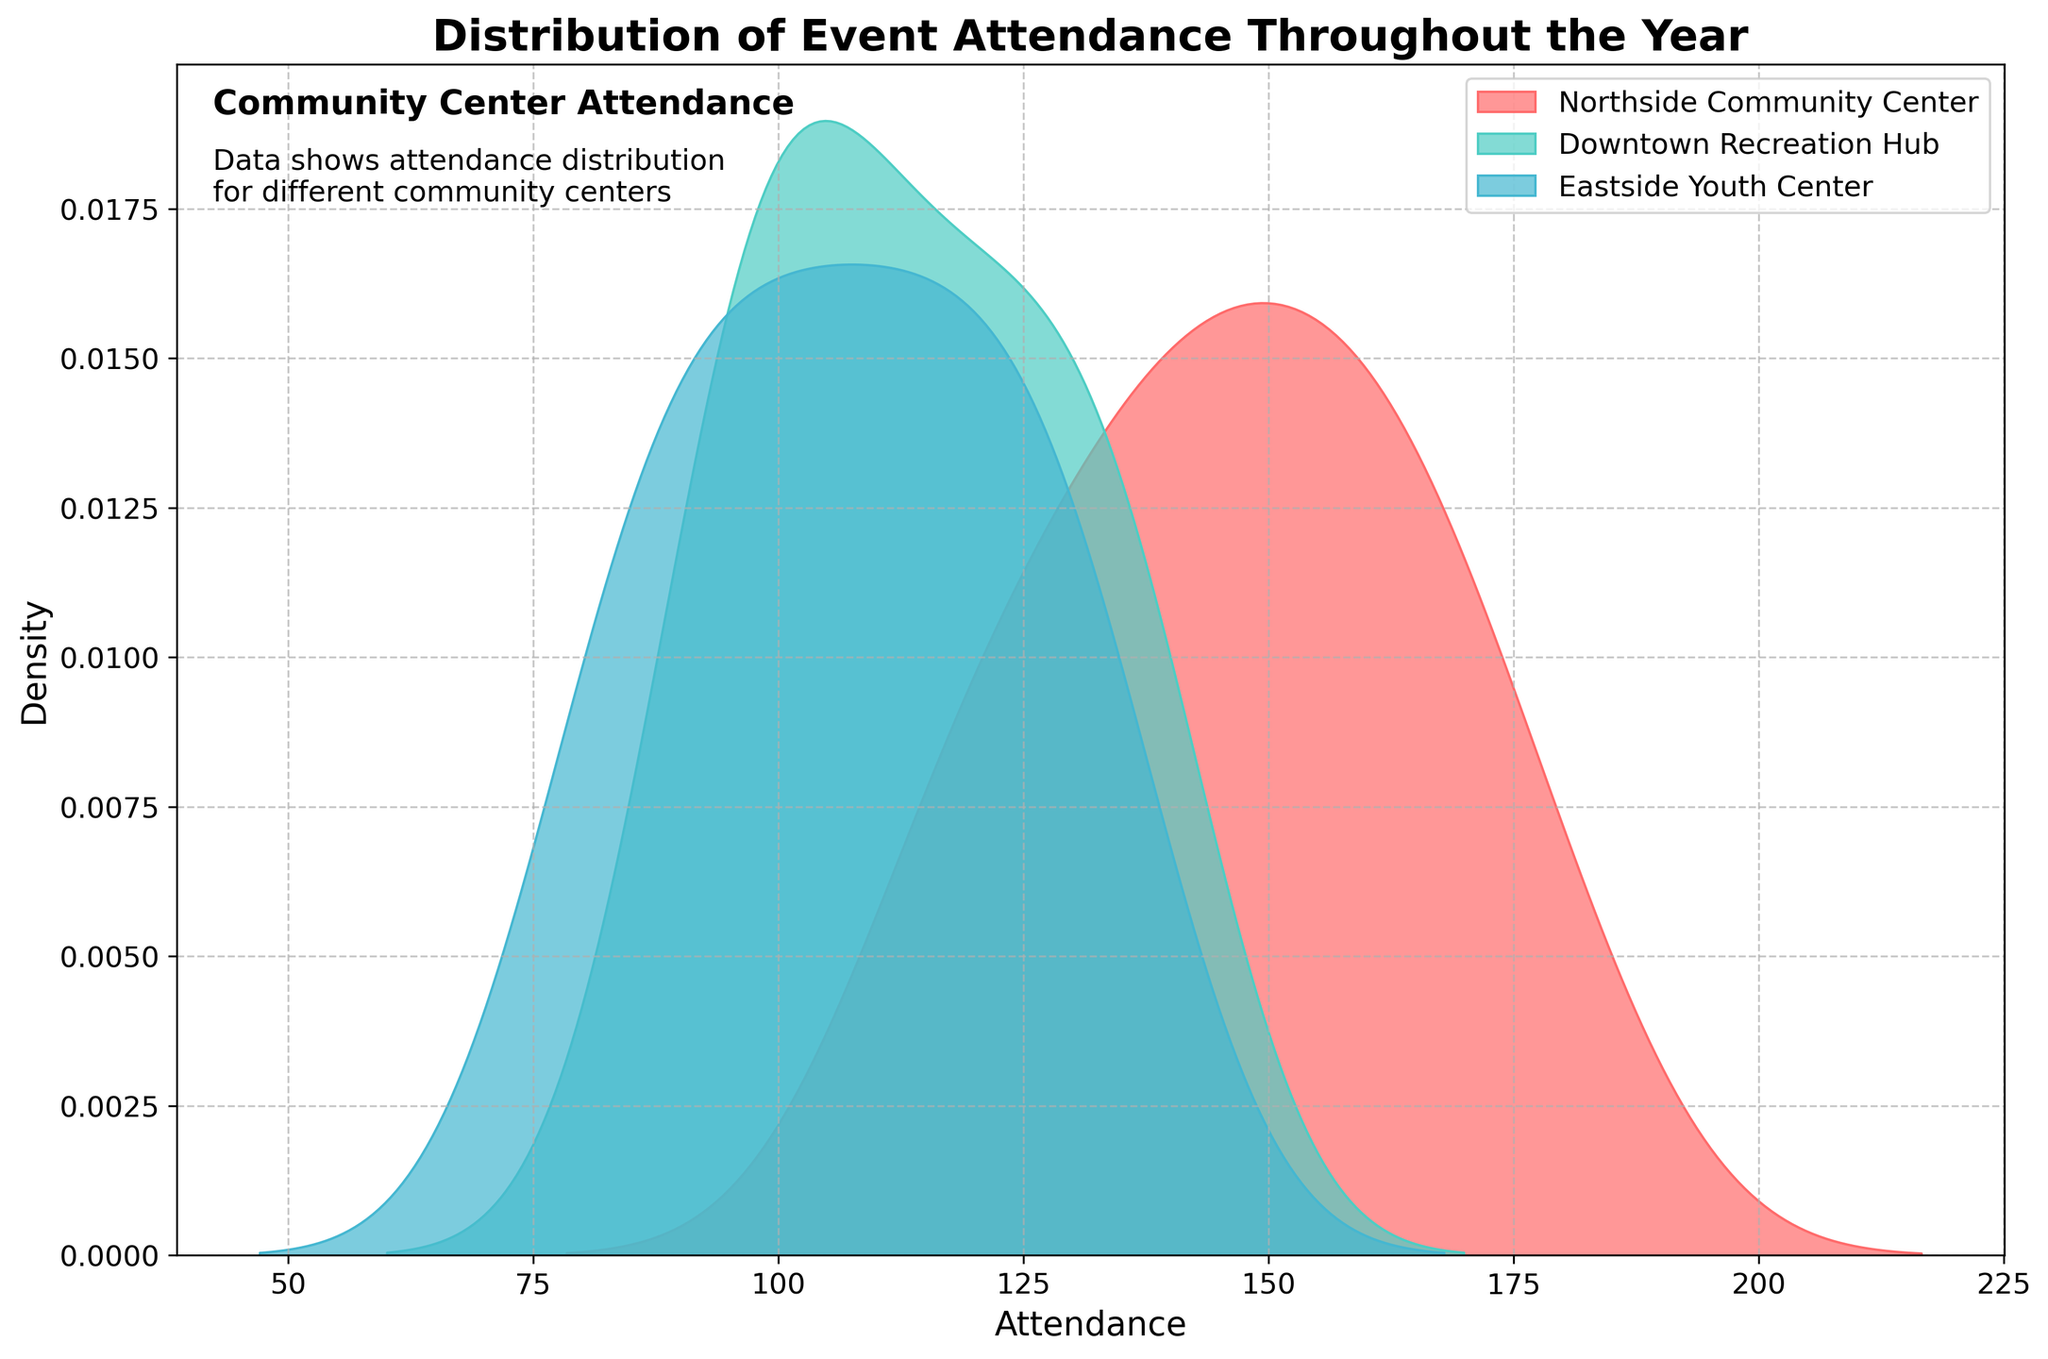What is the title of the figure? The title is located at the top of the plot and usually provides a brief description of what the figure is showing.
Answer: 'Distribution of Event Attendance Throughout the Year' What are the labels for the X and Y axes? The x-axis and y-axis labels provide information about the data represented on those axes. The x-axis represents 'Attendance', and the y-axis represents 'Density'.
Answer: Attendance (x-axis), Density (y-axis) How many community centers are represented in the plot? The plot legend shows different labels for each community center. By counting these labels, we can determine that there are three community centers: Northside Community Center, Downtown Recreation Hub, and Eastside Youth Center.
Answer: Three Which community center has the highest peak attendance density? The peak attendance density can be identified by looking at the highest point of each distribution curve in the plot. The distribution curve for the Northside Community Center has the highest peak.
Answer: Northside Community Center What range of attendance has the lowest density for the Eastside Youth Center? The density is lowest in the range where the curve for the Eastside Youth Center is closest to the x-axis or even touching it.
Answer: Below 80 and above 135 How does the distribution curve of Downtown Recreation Hub compare to that of Northside Community Center? We can compare the shapes, peaks, and widths of their distribution curves. The Downtown Recreation Hub curve is lower and narrower with a peak around 135, whereas the Northside Community Center curve is higher and wider with a peak around 160.
Answer: Narrower and lower; peak around 135 for Downtown Recreation Hub, wider and higher; peak around 160 for Northside Community Center What is the densest attendance range for Northside Community Center? The densest range can be found by noting where the distribution curve for Northside Community Center reaches its peak and maintains the most density. This is around the attendance values of 160-170.
Answer: 160-170 Which community center shows a consistent increase in attendance throughout the year? By observing the plot, we see that the distribution curve for Northside Community Center stretches broader towards higher attendance, indicating a consistent rise in attendance throughout the dataset.
Answer: Northside Community Center In which months is the attendance likely to be highest for Eastside Youth Center? Considering the density plot for Eastside Youth Center shows a peak at higher attendance, which corresponds to the later months in the dataset (August to December), these months likely have the highest attendance.
Answer: August to December To which community center does the densest distribution curve belong? The densest distribution curve, with the smallest range and highest density for most values, belongs to the Northside Community Center.
Answer: Northside Community Center Which community center has a wider distribution range in attendance data? By observing the spread of each distribution curve from left to right across the x-axis, we determine that Northside Community Center has the widest distribution range.
Answer: Northside Community Center 